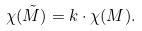Convert formula to latex. <formula><loc_0><loc_0><loc_500><loc_500>\chi ( \tilde { M } ) = k \cdot \chi ( M ) .</formula> 